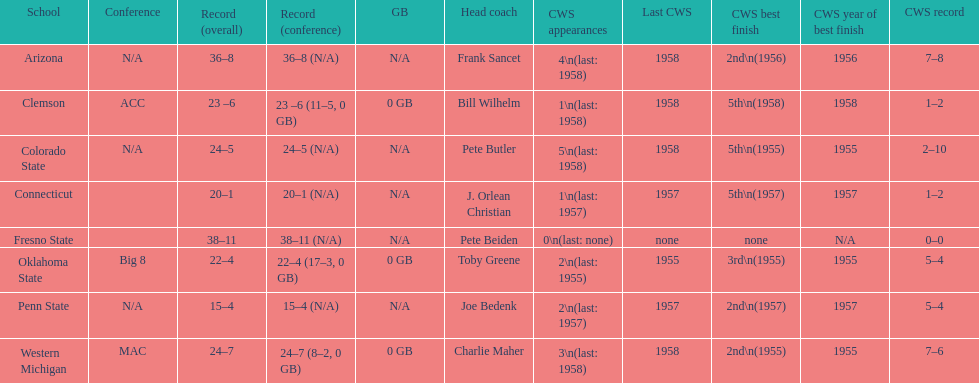Which team did not have more than 16 wins? Penn State. 